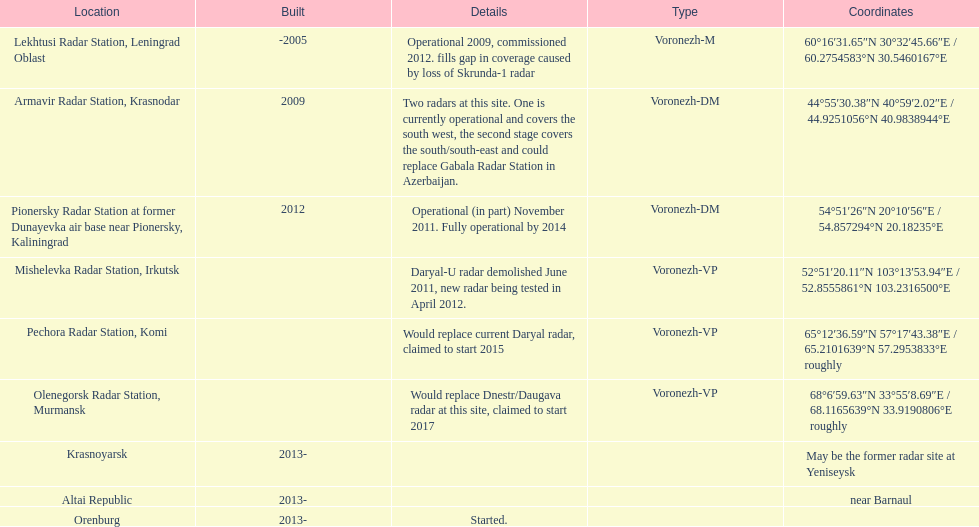How many voronezh radars were constructed prior to 2010? 2. 